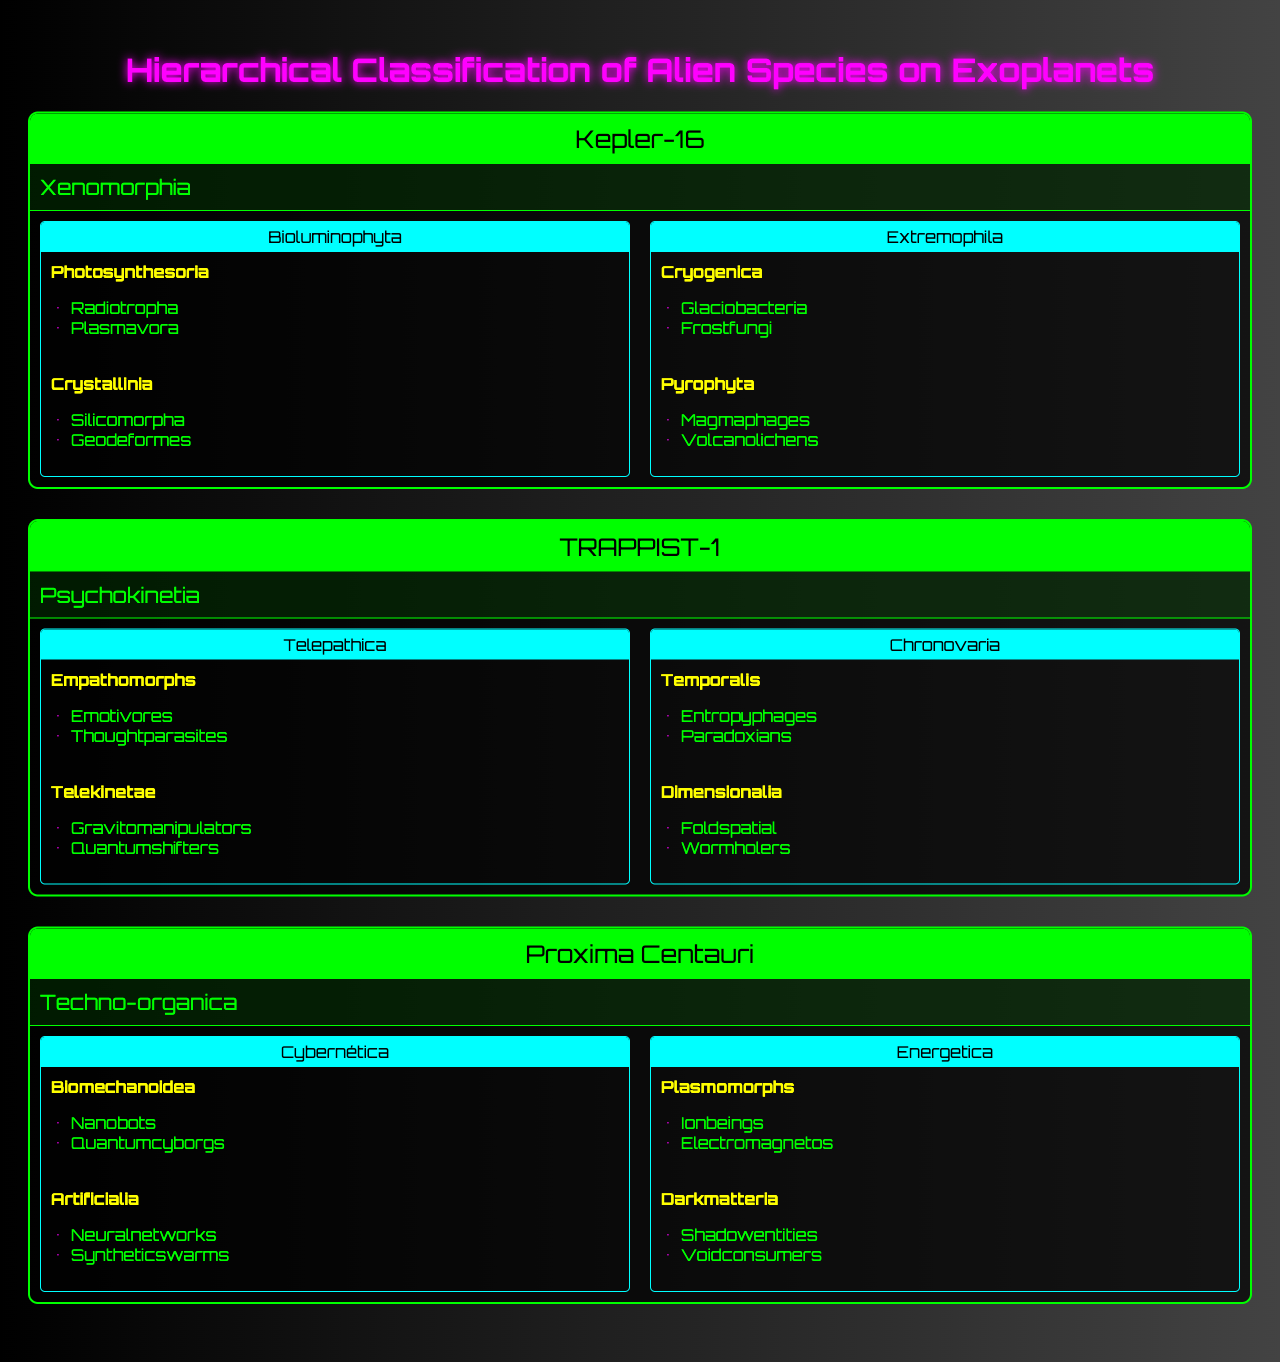What is the total number of alien species listed across all exoplanet systems? By examining each exoplanet system, we can see that Kepler-16 has 1 alien species, TRAPPIST-1 has 1 alien species, and Proxima Centauri also has 1 alien species. Adding them together gives us a total of 1 + 1 + 1 = 3 alien species.
Answer: 3 Which exoplanet system has the kingdom "Xenomorphia"? Looking at the table, "Xenomorphia" is listed under the Kepler-16 system as the kingdom of its alien species.
Answer: Kepler-16 How many phyla are there under the kingdom "Psychokinetia"? The phylum section under "Psychokinetia" in the TRAPPIST-1 system shows two distinct phyla: Telepathica and Chronovaria. Thus, there are 2 phyla.
Answer: 2 Is "Radiotropha" an order under any class in the Xenomorphia kingdom? By checking the specified classes under Xenomorphia, "Radiotropha" is listed as an order under the class Photosynthesoria, confirming the statement to be true.
Answer: Yes Which kingdom has the most classes listed? Reviewing each kingdom, "Techno-organica" contains 4 classes (2 from Cybernética and 2 from Energetica), while both "Xenomorphia" and "Psychokinetia" have 4 classes combined. Thus, Techno-organica leads with the most at 4 classes.
Answer: Techno-organica What is the relationship between the order "Frostfungi" and the kingdom it belongs to? "Frostfungi" is listed as an order under the class Cryogenica, which belongs to the phylum Extremophila, ultimately categorizing it under the kingdom Xenomorphia. It is part of the kingdom that includes entities adapted to extreme environments.
Answer: Xenomorphia How many orders does the class "Artificialia" include? The class "Artificialia" has two orders listed: Neuralnetworks and Syntheticswarms. Therefore, it includes 2 orders.
Answer: 2 Which exoplanet has a kingdom that includes "Voidconsumers"? Scanning the kingdoms, "Voidconsumers" is found under the order of Darkmatteria, which belongs to the kingdom Techno-organica on Proxima Centauri.
Answer: Proxima Centauri Are there any classes under the phylum "Telepathica" that include the order "Thoughtparasites"? Yes, "Thoughtparasites" is listed as one of the orders under the class Empathomorphs, which falls under the phylum Telepathica of the kingdom Psychokinetia. Thus, the answer is true.
Answer: Yes How many classes are present in the kingdom "Energetica"? Under the kingdom "Energetica", there are 2 classes: Plasmomorphs and Darkmatteria. Thus, the total number of classes is 2.
Answer: 2 Which kingdom contains the order "Quantumshifters"? The kingdom Psychokinetia contains the order Quantumshifters, which can be found under the class Telekinetae.
Answer: Psychokinetia 